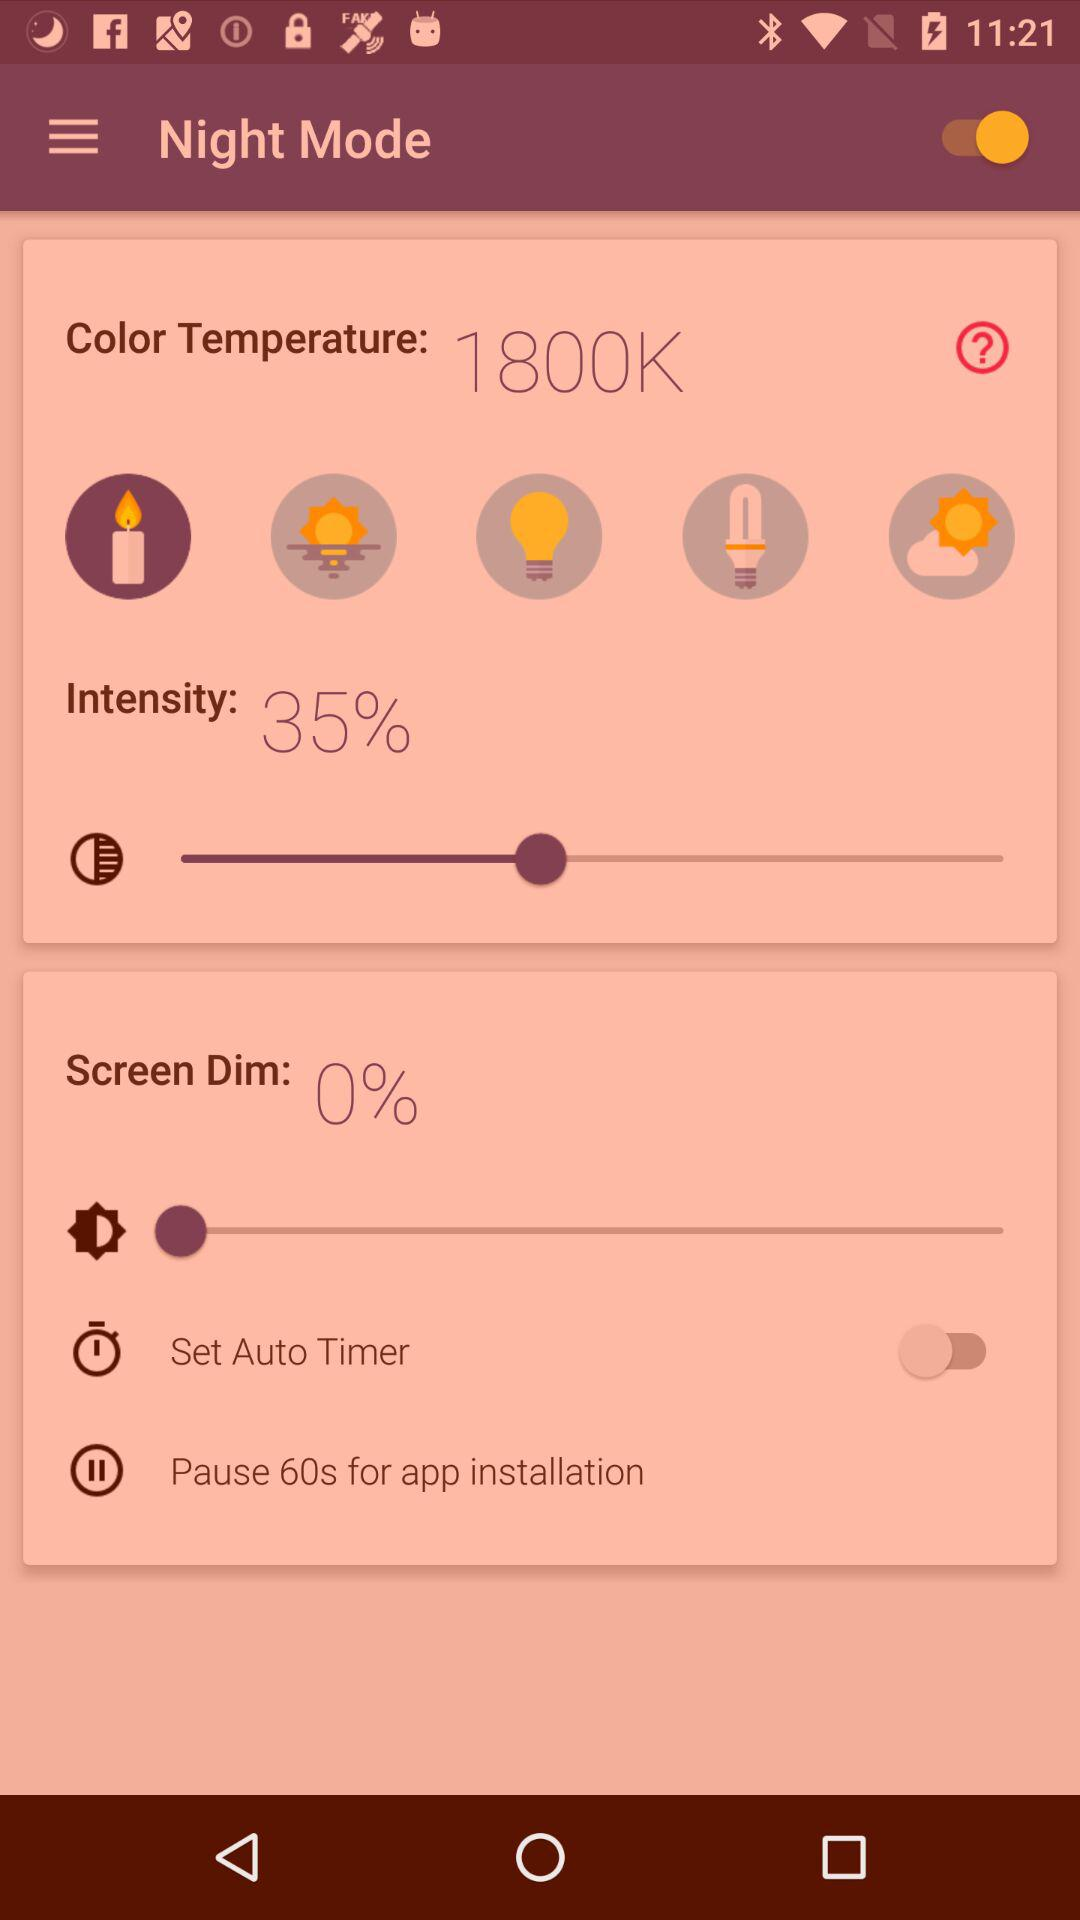What is the set intensity? The set intensity is 35%. 